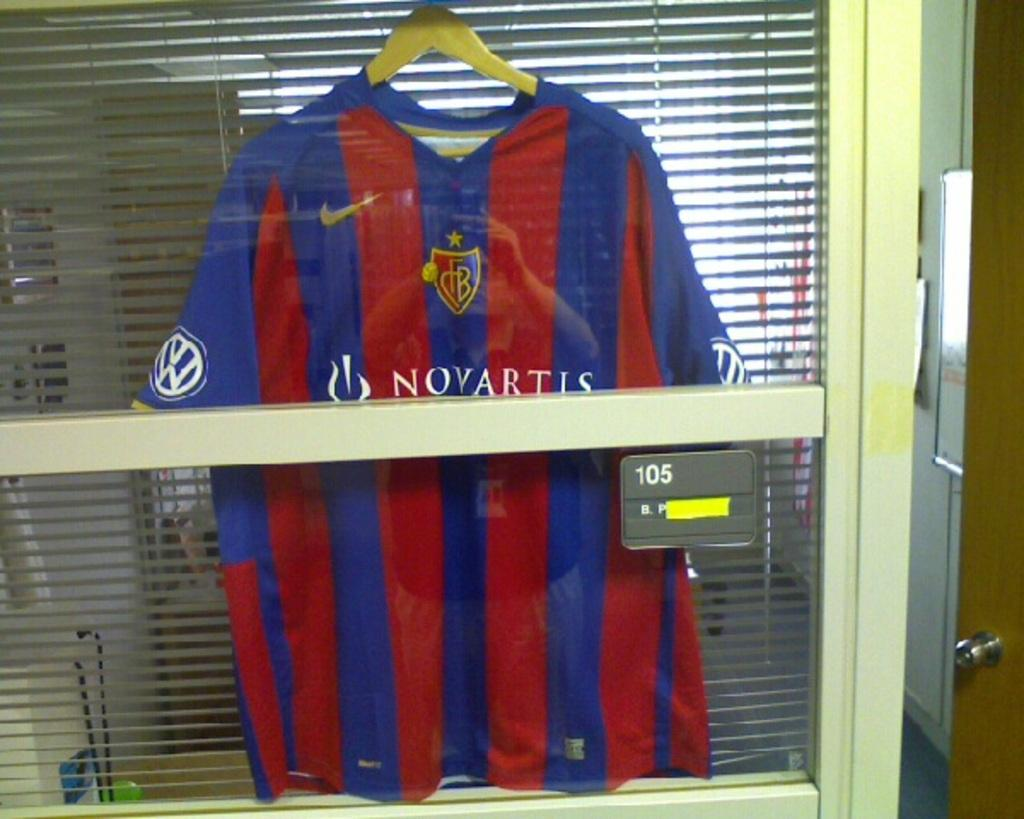<image>
Create a compact narrative representing the image presented. A shirt hangs with the Novartis logo on it. 